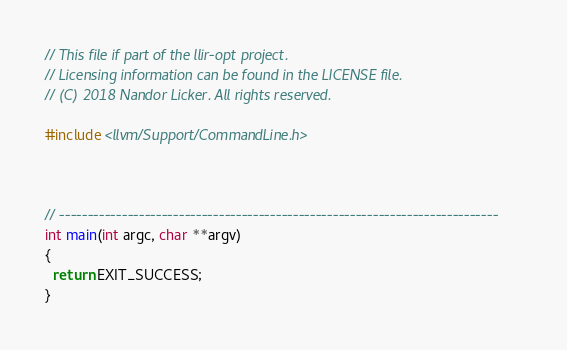Convert code to text. <code><loc_0><loc_0><loc_500><loc_500><_C++_>// This file if part of the llir-opt project.
// Licensing information can be found in the LICENSE file.
// (C) 2018 Nandor Licker. All rights reserved.

#include <llvm/Support/CommandLine.h>



// -----------------------------------------------------------------------------
int main(int argc, char **argv)
{
  return EXIT_SUCCESS;
}
</code> 